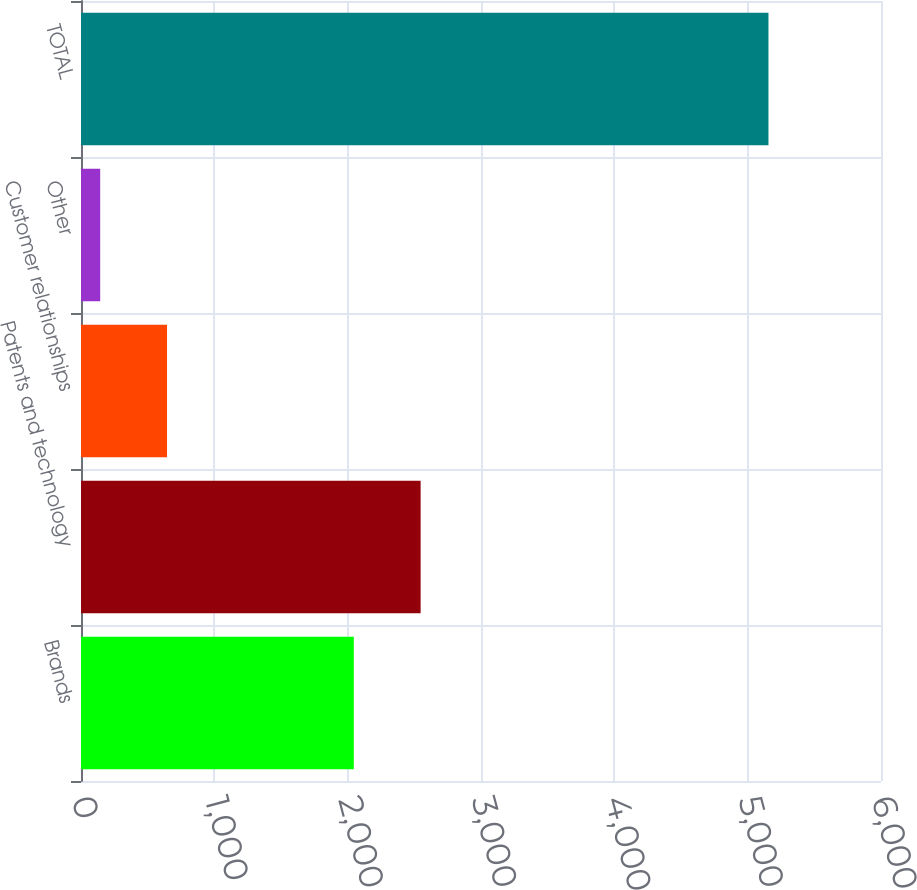Convert chart. <chart><loc_0><loc_0><loc_500><loc_500><bar_chart><fcel>Brands<fcel>Patents and technology<fcel>Customer relationships<fcel>Other<fcel>TOTAL<nl><fcel>2046<fcel>2547.2<fcel>645.2<fcel>144<fcel>5156<nl></chart> 